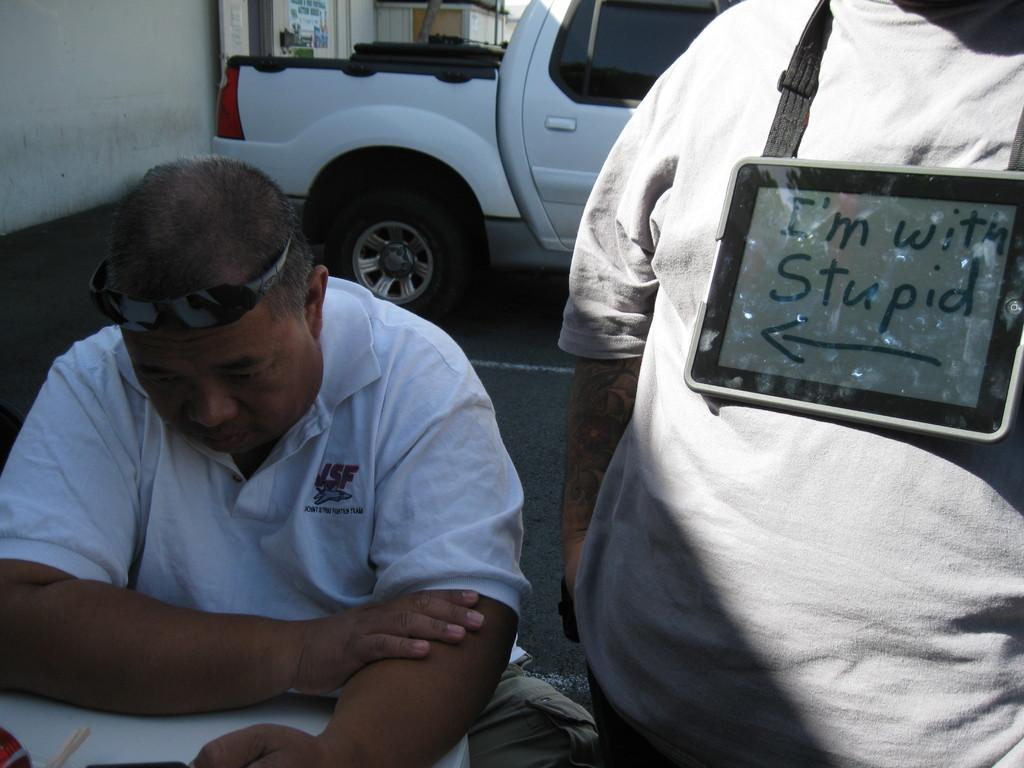What is the person in the image doing? There is a person sitting on a chair in the image. Is there anyone else in the image? Yes, there is a person standing beside the person sitting on the chair. What can be seen in the background of the image? There is a vehicle visible in the background of the image. Can you describe the location of the vehicle? The vehicle is on a road. How many arms does the person sitting on the chair have in the image? The person sitting on the chair has two arms, as humans typically have two arms. However, this information cannot be determined from the image alone, as it only shows the person sitting on the chair and not their arms. 